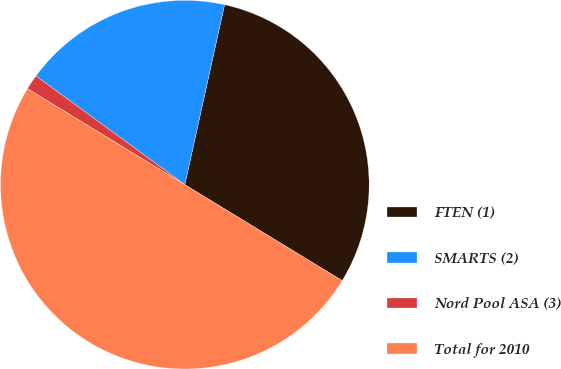Convert chart. <chart><loc_0><loc_0><loc_500><loc_500><pie_chart><fcel>FTEN (1)<fcel>SMARTS (2)<fcel>Nord Pool ASA (3)<fcel>Total for 2010<nl><fcel>30.26%<fcel>18.42%<fcel>1.32%<fcel>50.0%<nl></chart> 